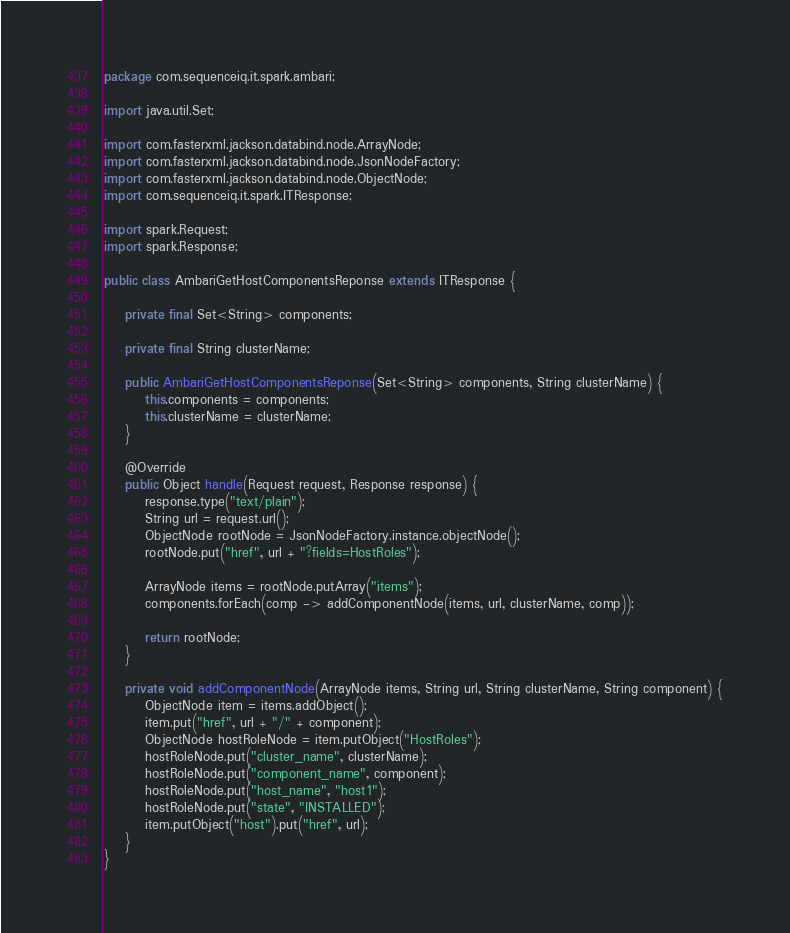Convert code to text. <code><loc_0><loc_0><loc_500><loc_500><_Java_>package com.sequenceiq.it.spark.ambari;

import java.util.Set;

import com.fasterxml.jackson.databind.node.ArrayNode;
import com.fasterxml.jackson.databind.node.JsonNodeFactory;
import com.fasterxml.jackson.databind.node.ObjectNode;
import com.sequenceiq.it.spark.ITResponse;

import spark.Request;
import spark.Response;

public class AmbariGetHostComponentsReponse extends ITResponse {

    private final Set<String> components;

    private final String clusterName;

    public AmbariGetHostComponentsReponse(Set<String> components, String clusterName) {
        this.components = components;
        this.clusterName = clusterName;
    }

    @Override
    public Object handle(Request request, Response response) {
        response.type("text/plain");
        String url = request.url();
        ObjectNode rootNode = JsonNodeFactory.instance.objectNode();
        rootNode.put("href", url + "?fields=HostRoles");

        ArrayNode items = rootNode.putArray("items");
        components.forEach(comp -> addComponentNode(items, url, clusterName, comp));

        return rootNode;
    }

    private void addComponentNode(ArrayNode items, String url, String clusterName, String component) {
        ObjectNode item = items.addObject();
        item.put("href", url + "/" + component);
        ObjectNode hostRoleNode = item.putObject("HostRoles");
        hostRoleNode.put("cluster_name", clusterName);
        hostRoleNode.put("component_name", component);
        hostRoleNode.put("host_name", "host1");
        hostRoleNode.put("state", "INSTALLED");
        item.putObject("host").put("href", url);
    }
}
</code> 